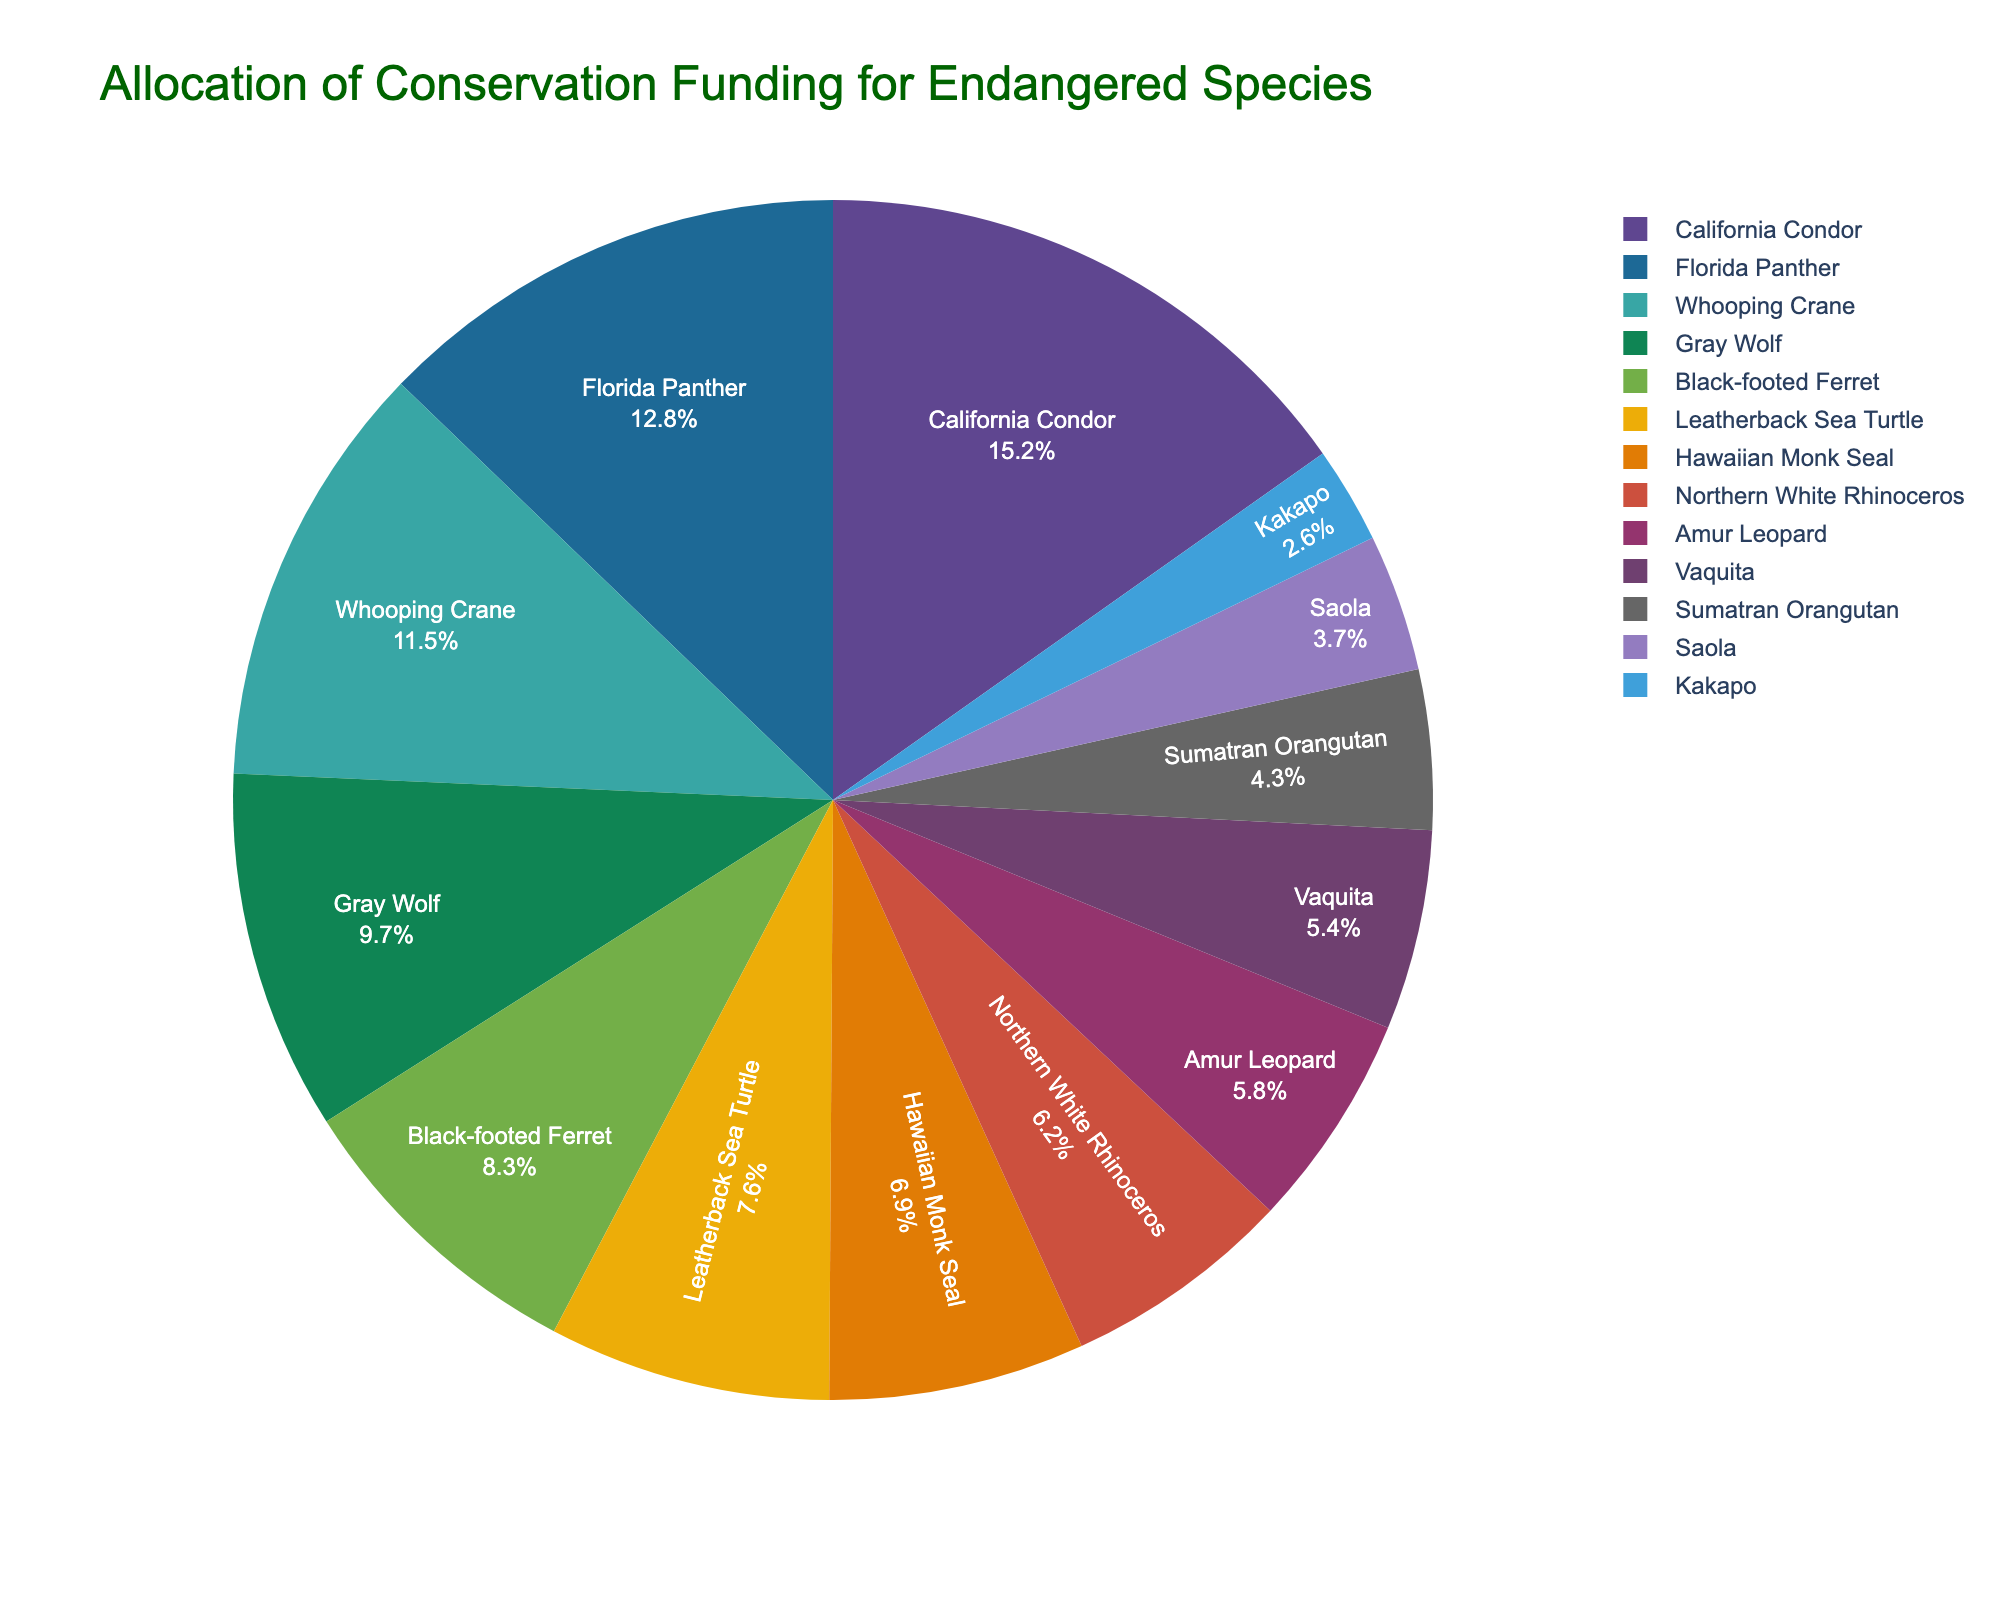Which species receives the highest percentage of funding? The slice labeled "California Condor" is the largest in the pie chart. The hover tooltip confirms the funding percentage as 15.2%.
Answer: California Condor What is the total percentage of funding allocated to the Florida Panther and the Whooping Crane? The Florida Panther has 12.8% and the Whooping Crane has 11.5%. Adding them: 12.8% + 11.5% = 24.3%.
Answer: 24.3% How much more funding does the California Condor receive compared to the Vaquita? California Condor has 15.2%, and Vaquita has 5.4%. Subtracting: 15.2% - 5.4% = 9.8%.
Answer: 9.8% Which species receives less funding: the Hawaiian Monk Seal or the Amur Leopard? Comparing the slices, the Hawaiian Monk Seal shows 6.9% while the Amur Leopard has 5.8%.
Answer: Amur Leopard What percentage of the total funding goes to species receiving less than 5% each? Species with less than 5%: Sumatran Orangutan (4.3%), Saola (3.7%), Kakapo (2.6%). Adding: 4.3% + 3.7% + 2.6% = 10.6%.
Answer: 10.6% What is the combined funding percentage for the Gray Wolf, Black-footed Ferret, and Leatherback Sea Turtle? Gray Wolf has 9.7%, Black-footed Ferret has 8.3%, and Leatherback Sea Turtle has 7.6%. Adding: 9.7% + 8.3% + 7.6% = 25.6%.
Answer: 25.6% How does the funding for the Northern White Rhinoceros compare to that of the Saola? Northern White Rhinoceros has 6.2% and Saola has 3.7%. Since 6.2% is greater than 3.7%, the Rhinoceros receives more funding.
Answer: Northern White Rhinoceros Which species occupies the smallest slice of the pie chart? The smallest slice is labeled "Kakapo" with a funding percentage of 2.6%, confirmed by its small visual proportion in the chart.
Answer: Kakapo What is the difference between the funding percentages of the Gray Wolf and the Black-footed Ferret? The Gray Wolf has 9.7% and the Black-footed Ferret has 8.3%. Subtracting: 9.7% - 8.3% = 1.4%.
Answer: 1.4% If the funding for the Vaquita were doubled, what would its percentage be? The Vaquita has 5.4%. Doubling this: 5.4% x 2 = 10.8%.
Answer: 10.8% 